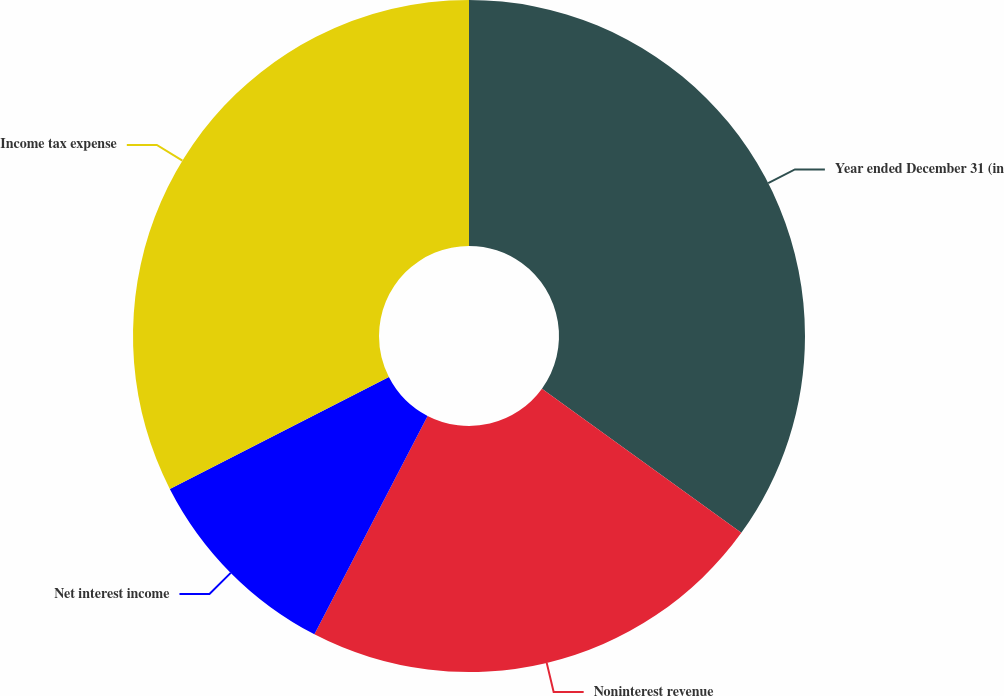<chart> <loc_0><loc_0><loc_500><loc_500><pie_chart><fcel>Year ended December 31 (in<fcel>Noninterest revenue<fcel>Net interest income<fcel>Income tax expense<nl><fcel>34.96%<fcel>22.65%<fcel>9.87%<fcel>32.52%<nl></chart> 